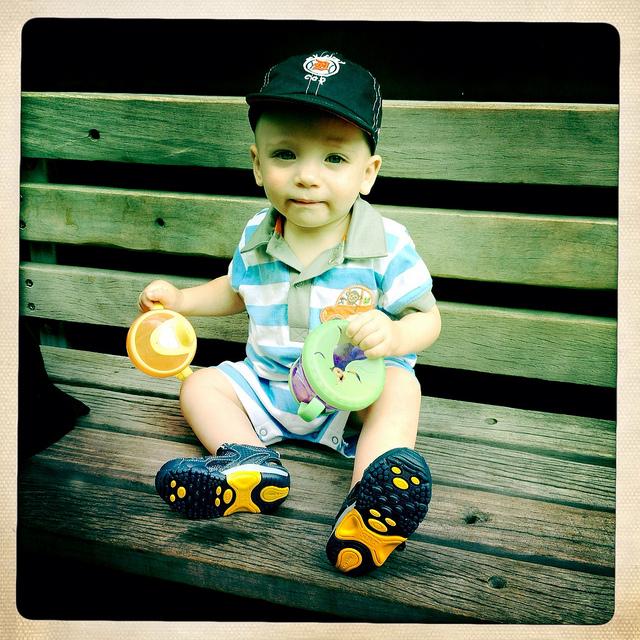What colors are the soles?
Be succinct. Yellow and black. How many cups is the baby holding?
Keep it brief. 2. What is on the baby's head?
Write a very short answer. Hat. 